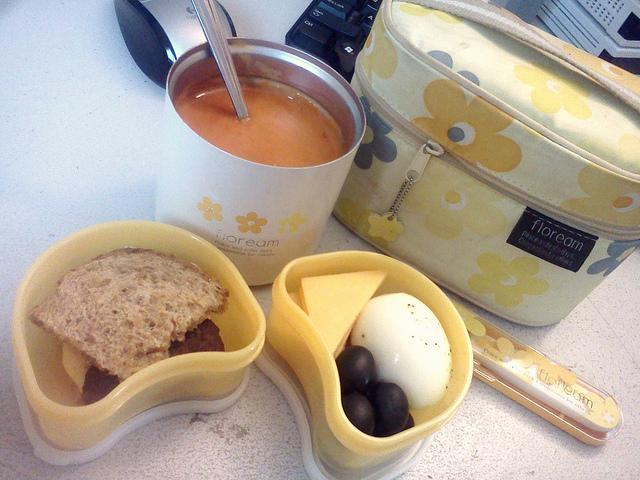What does the item in the can with the utensil look like?

Choices:
A) cake
B) soup
C) cat
D) pears soup 